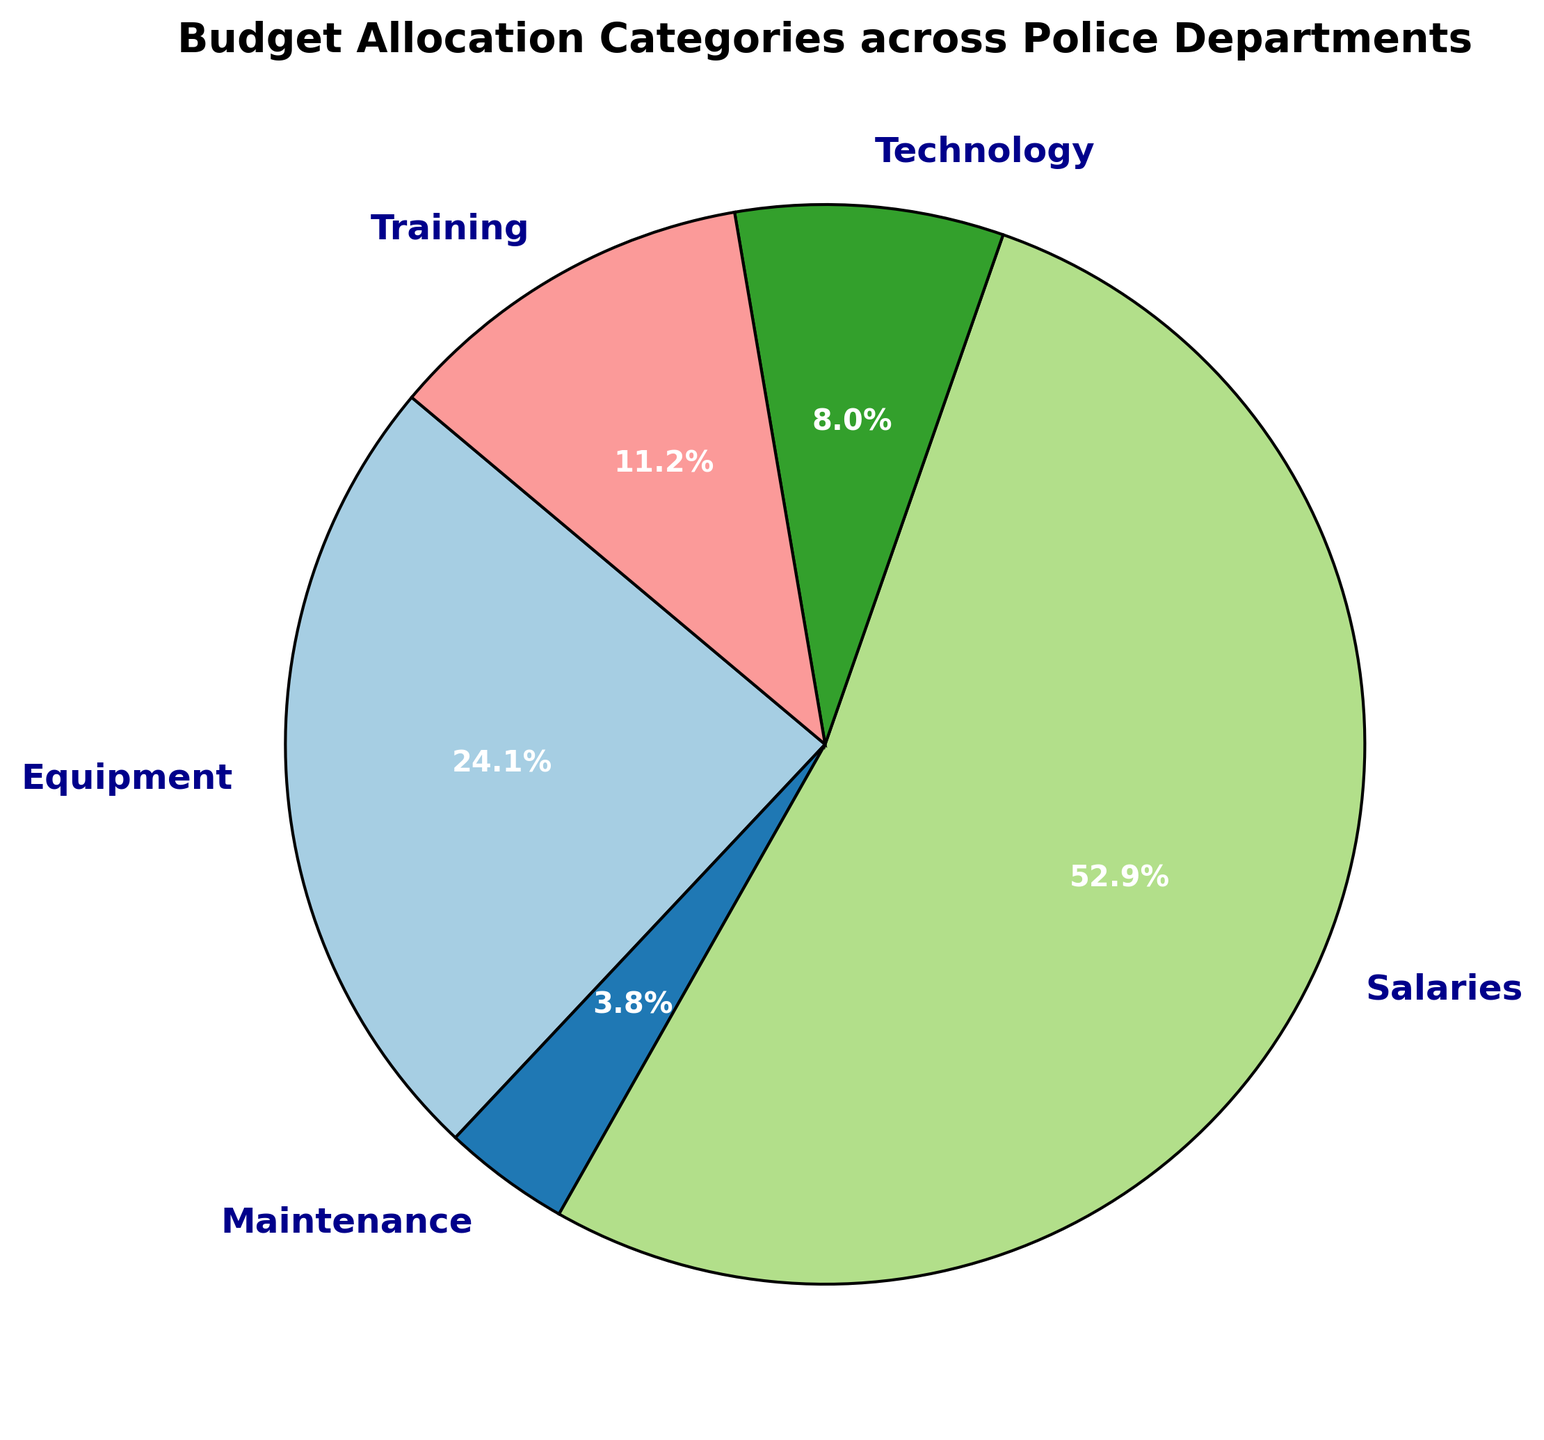What's the largest budget category for all departments? To find the largest budget category, look at the pie section with the largest area which usually corresponds to the highest percentage indicated by the labeled sections. The 'Salaries' section is the largest on the pie chart.
Answer: Salaries What percentage of the total budget is allocated to Equipment? Identify the 'Equipment' section on the pie chart and read the percentage labeled within it. According to the pie chart, 'Equipment' receives a certain percentage of the total. Look for this specific value.
Answer: x% What is the combined percentage for Maintenance and Technology budgets? To determine this, locate the 'Maintenance' and 'Technology' sections on the pie chart and add their percentages together. For instance, if Maintenance is 5% and Technology is 7%, add them to get 12%.
Answer: x% How does the Training budget compare to the Technology budget? Compare the sizes of the 'Training' and 'Technology' sections. Check their respective labeled percentages to determine which is larger or if they are different by any significant margin.
Answer: Training has a higher/lower/equal percentage than Technology What's the difference in percentage between Equipment and Maintenance budgets? Locate and note the percentages for 'Equipment' and 'Maintenance' from the pie chart. Subtract the Maintenance percentage from the Equipment percentage to find the difference. For example, if Equipment is 25% and Maintenance is 5%, then the difference is 20%.
Answer: x% 